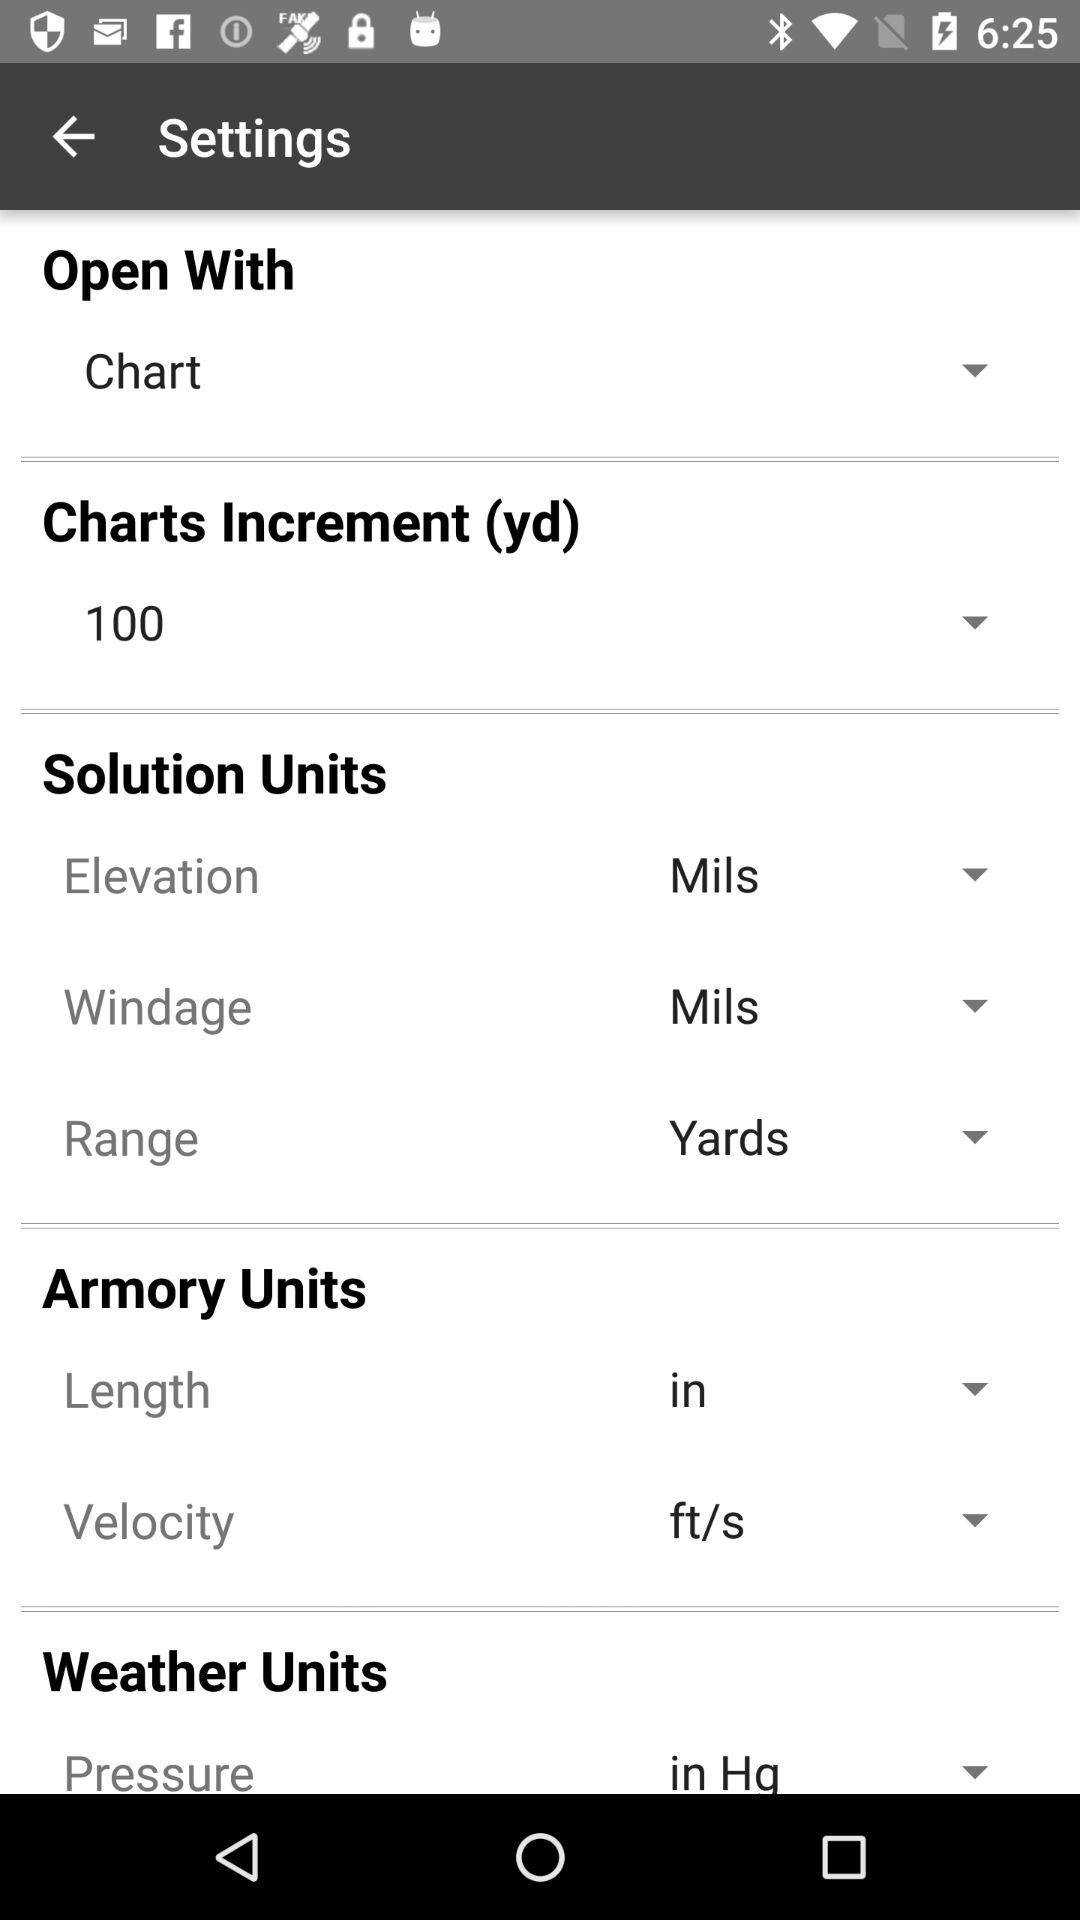Which is the selected option to "Open With"? The selected option to "Open With" is "Chart". 